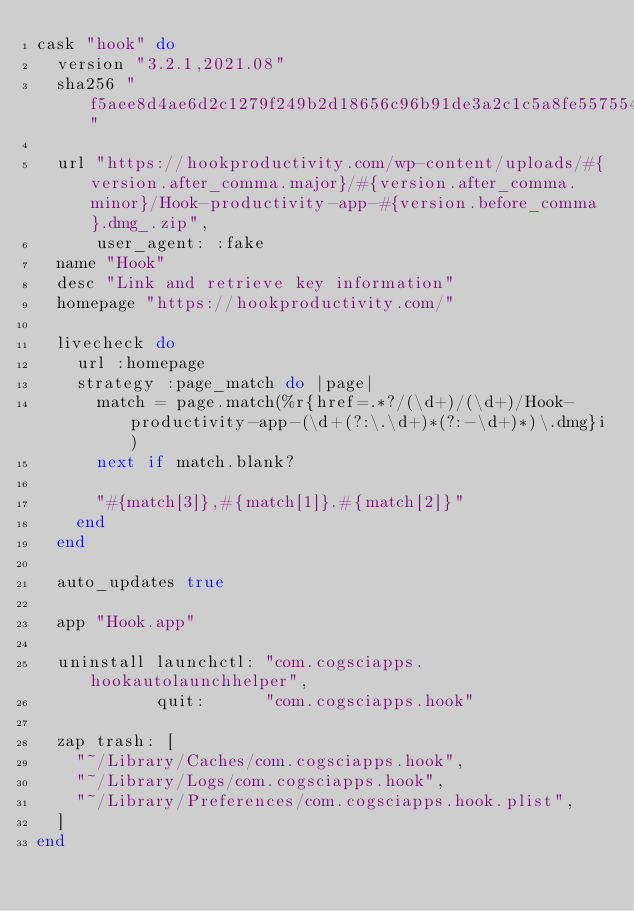<code> <loc_0><loc_0><loc_500><loc_500><_Ruby_>cask "hook" do
  version "3.2.1,2021.08"
  sha256 "f5aee8d4ae6d2c1279f249b2d18656c96b91de3a2c1c5a8fe557554e1bf9aee1"

  url "https://hookproductivity.com/wp-content/uploads/#{version.after_comma.major}/#{version.after_comma.minor}/Hook-productivity-app-#{version.before_comma}.dmg_.zip",
      user_agent: :fake
  name "Hook"
  desc "Link and retrieve key information"
  homepage "https://hookproductivity.com/"

  livecheck do
    url :homepage
    strategy :page_match do |page|
      match = page.match(%r{href=.*?/(\d+)/(\d+)/Hook-productivity-app-(\d+(?:\.\d+)*(?:-\d+)*)\.dmg}i)
      next if match.blank?

      "#{match[3]},#{match[1]}.#{match[2]}"
    end
  end

  auto_updates true

  app "Hook.app"

  uninstall launchctl: "com.cogsciapps.hookautolaunchhelper",
            quit:      "com.cogsciapps.hook"

  zap trash: [
    "~/Library/Caches/com.cogsciapps.hook",
    "~/Library/Logs/com.cogsciapps.hook",
    "~/Library/Preferences/com.cogsciapps.hook.plist",
  ]
end
</code> 